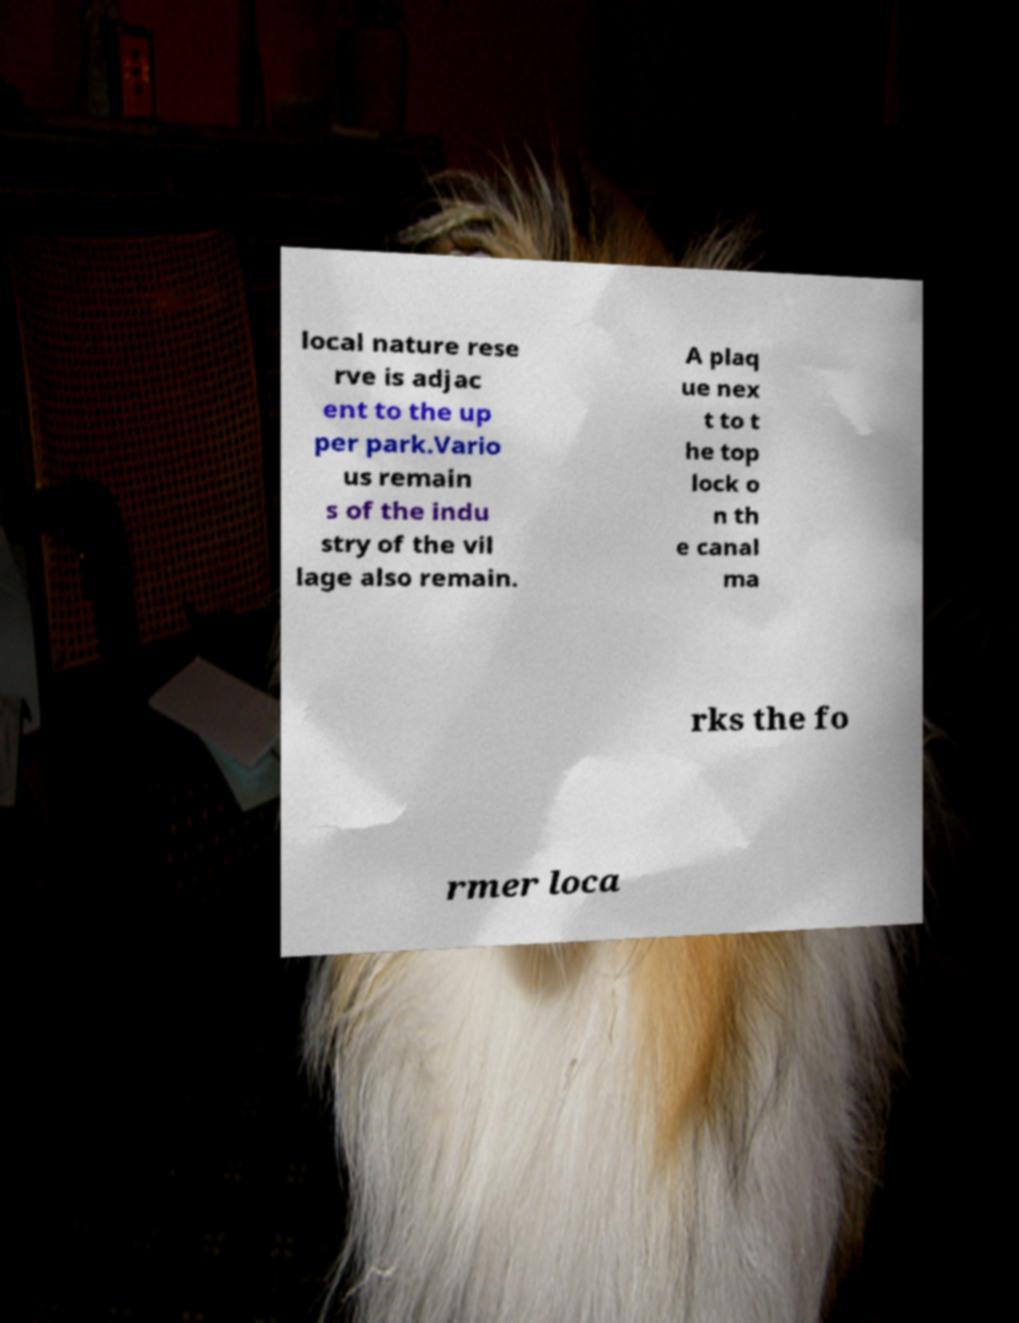For documentation purposes, I need the text within this image transcribed. Could you provide that? local nature rese rve is adjac ent to the up per park.Vario us remain s of the indu stry of the vil lage also remain. A plaq ue nex t to t he top lock o n th e canal ma rks the fo rmer loca 